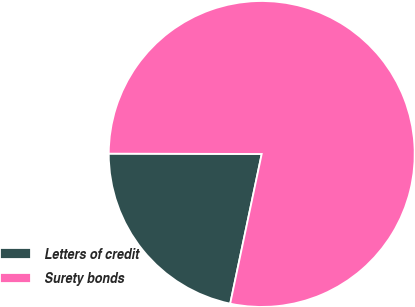<chart> <loc_0><loc_0><loc_500><loc_500><pie_chart><fcel>Letters of credit<fcel>Surety bonds<nl><fcel>21.73%<fcel>78.27%<nl></chart> 